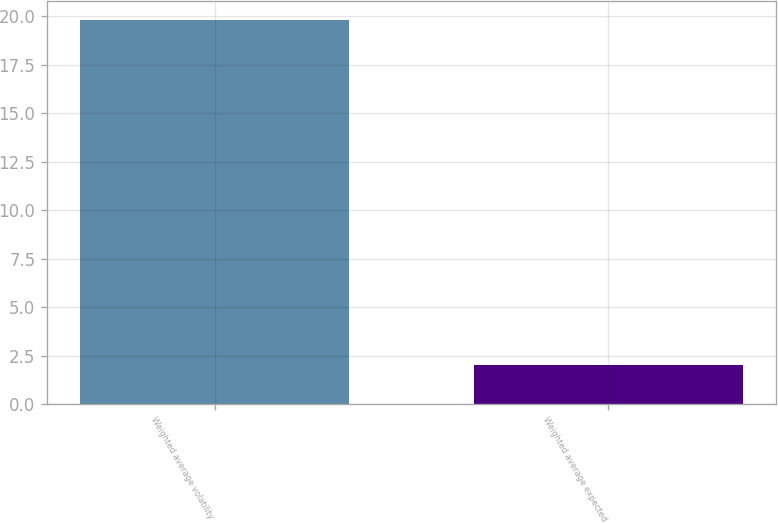Convert chart. <chart><loc_0><loc_0><loc_500><loc_500><bar_chart><fcel>Weighted average volatility<fcel>Weighted average expected<nl><fcel>19.8<fcel>2<nl></chart> 